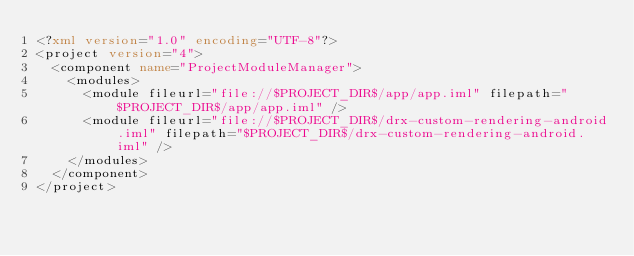Convert code to text. <code><loc_0><loc_0><loc_500><loc_500><_XML_><?xml version="1.0" encoding="UTF-8"?>
<project version="4">
  <component name="ProjectModuleManager">
    <modules>
      <module fileurl="file://$PROJECT_DIR$/app/app.iml" filepath="$PROJECT_DIR$/app/app.iml" />
      <module fileurl="file://$PROJECT_DIR$/drx-custom-rendering-android.iml" filepath="$PROJECT_DIR$/drx-custom-rendering-android.iml" />
    </modules>
  </component>
</project></code> 